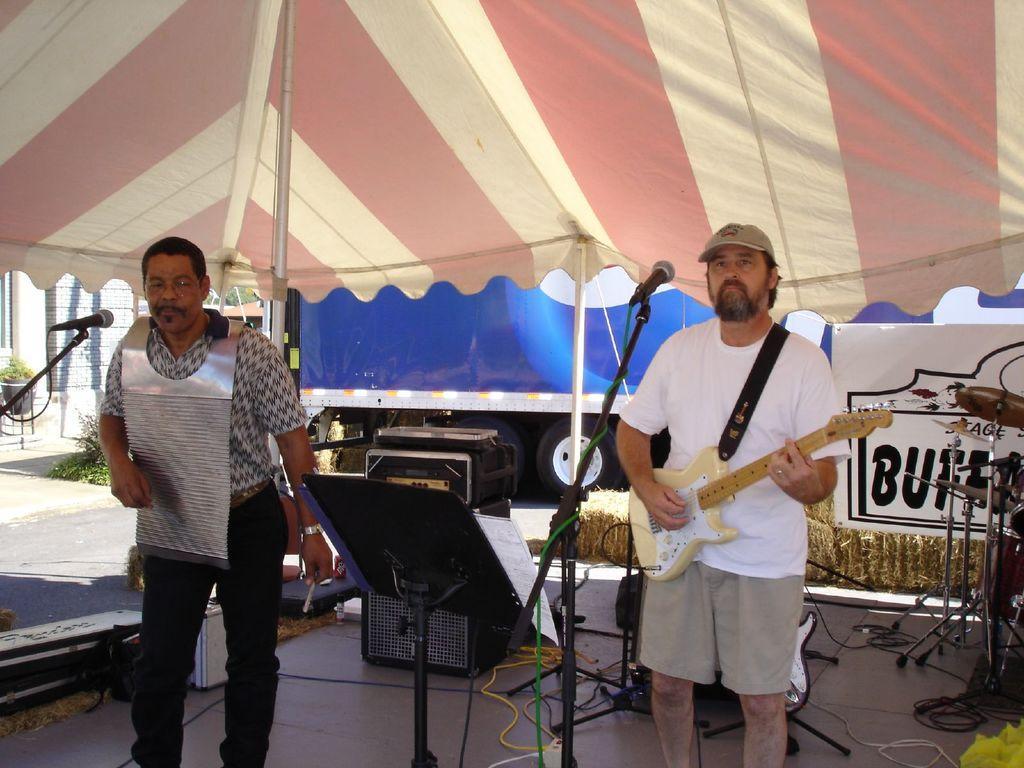How would you summarize this image in a sentence or two? In this image I can see two people are standing in front of the mic. One person is holding the guitar and these people are under the tent. At the back there is a blue color vehicle. To the right there is a flower pot. 